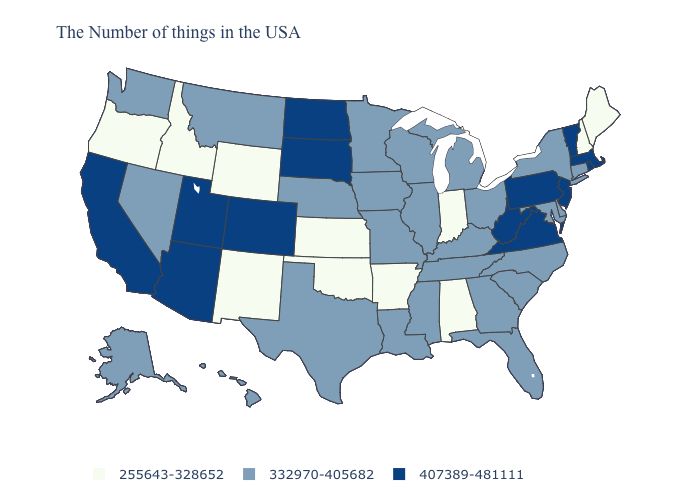Name the states that have a value in the range 407389-481111?
Be succinct. Massachusetts, Rhode Island, Vermont, New Jersey, Pennsylvania, Virginia, West Virginia, South Dakota, North Dakota, Colorado, Utah, Arizona, California. Name the states that have a value in the range 255643-328652?
Concise answer only. Maine, New Hampshire, Indiana, Alabama, Arkansas, Kansas, Oklahoma, Wyoming, New Mexico, Idaho, Oregon. Does Oregon have the same value as Idaho?
Concise answer only. Yes. What is the value of Missouri?
Write a very short answer. 332970-405682. Which states have the lowest value in the Northeast?
Write a very short answer. Maine, New Hampshire. Does Maine have the lowest value in the Northeast?
Write a very short answer. Yes. What is the value of Michigan?
Write a very short answer. 332970-405682. What is the value of Connecticut?
Concise answer only. 332970-405682. Name the states that have a value in the range 255643-328652?
Quick response, please. Maine, New Hampshire, Indiana, Alabama, Arkansas, Kansas, Oklahoma, Wyoming, New Mexico, Idaho, Oregon. Does Virginia have a higher value than Colorado?
Keep it brief. No. What is the lowest value in the USA?
Short answer required. 255643-328652. What is the value of New Hampshire?
Be succinct. 255643-328652. Name the states that have a value in the range 255643-328652?
Write a very short answer. Maine, New Hampshire, Indiana, Alabama, Arkansas, Kansas, Oklahoma, Wyoming, New Mexico, Idaho, Oregon. Which states have the lowest value in the Northeast?
Give a very brief answer. Maine, New Hampshire. What is the value of West Virginia?
Keep it brief. 407389-481111. 